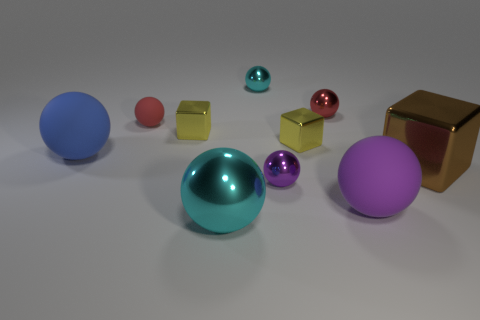What is the size of the blue rubber thing that is the same shape as the big purple matte thing?
Offer a very short reply. Large. Is the number of purple balls on the left side of the large blue rubber ball less than the number of things?
Offer a terse response. Yes. There is another big metallic thing that is the same shape as the big blue thing; what is its color?
Keep it short and to the point. Cyan. Do the cyan shiny object that is in front of the red shiny sphere and the red matte object have the same size?
Offer a terse response. No. There is a yellow thing that is to the right of the tiny thing in front of the large shiny cube; what is its size?
Your answer should be compact. Small. Is the large cyan sphere made of the same material as the small object in front of the large cube?
Ensure brevity in your answer.  Yes. Are there fewer tiny purple objects that are in front of the large blue object than blocks right of the big purple matte sphere?
Provide a short and direct response. No. There is a big block that is the same material as the tiny purple sphere; what is its color?
Make the answer very short. Brown. There is a tiny metallic ball behind the red shiny ball; is there a tiny red object that is to the right of it?
Provide a short and direct response. Yes. What color is the matte object that is the same size as the red metal object?
Make the answer very short. Red. 